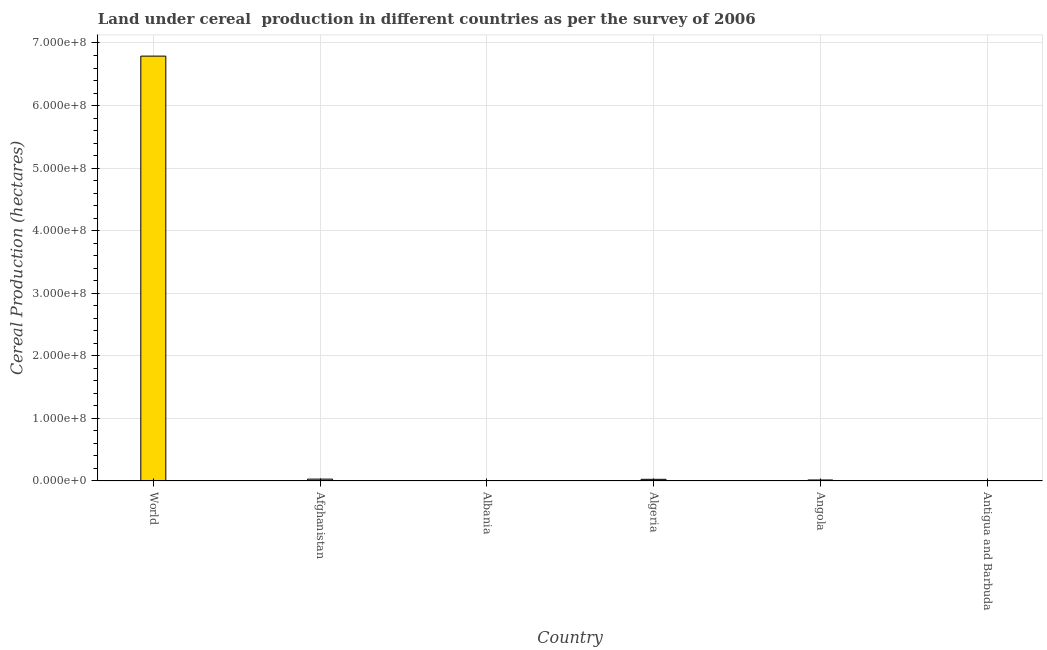Does the graph contain grids?
Ensure brevity in your answer.  Yes. What is the title of the graph?
Make the answer very short. Land under cereal  production in different countries as per the survey of 2006. What is the label or title of the X-axis?
Make the answer very short. Country. What is the label or title of the Y-axis?
Offer a very short reply. Cereal Production (hectares). What is the land under cereal production in Angola?
Offer a very short reply. 1.62e+06. Across all countries, what is the maximum land under cereal production?
Ensure brevity in your answer.  6.79e+08. In which country was the land under cereal production maximum?
Provide a short and direct response. World. In which country was the land under cereal production minimum?
Give a very brief answer. Antigua and Barbuda. What is the sum of the land under cereal production?
Give a very brief answer. 6.86e+08. What is the difference between the land under cereal production in Angola and World?
Offer a very short reply. -6.77e+08. What is the average land under cereal production per country?
Provide a succinct answer. 1.14e+08. What is the median land under cereal production?
Offer a very short reply. 2.15e+06. In how many countries, is the land under cereal production greater than 220000000 hectares?
Provide a short and direct response. 1. What is the ratio of the land under cereal production in Antigua and Barbuda to that in World?
Ensure brevity in your answer.  0. Is the land under cereal production in Afghanistan less than that in Antigua and Barbuda?
Your response must be concise. No. What is the difference between the highest and the second highest land under cereal production?
Your answer should be compact. 6.76e+08. Is the sum of the land under cereal production in Afghanistan and Antigua and Barbuda greater than the maximum land under cereal production across all countries?
Keep it short and to the point. No. What is the difference between the highest and the lowest land under cereal production?
Ensure brevity in your answer.  6.79e+08. How many bars are there?
Your response must be concise. 6. What is the difference between two consecutive major ticks on the Y-axis?
Your answer should be very brief. 1.00e+08. Are the values on the major ticks of Y-axis written in scientific E-notation?
Offer a terse response. Yes. What is the Cereal Production (hectares) of World?
Give a very brief answer. 6.79e+08. What is the Cereal Production (hectares) of Afghanistan?
Offer a very short reply. 2.99e+06. What is the Cereal Production (hectares) of Albania?
Give a very brief answer. 1.41e+05. What is the Cereal Production (hectares) of Algeria?
Offer a very short reply. 2.67e+06. What is the Cereal Production (hectares) in Angola?
Provide a short and direct response. 1.62e+06. What is the Cereal Production (hectares) of Antigua and Barbuda?
Offer a very short reply. 40. What is the difference between the Cereal Production (hectares) in World and Afghanistan?
Offer a very short reply. 6.76e+08. What is the difference between the Cereal Production (hectares) in World and Albania?
Your answer should be compact. 6.79e+08. What is the difference between the Cereal Production (hectares) in World and Algeria?
Your answer should be very brief. 6.76e+08. What is the difference between the Cereal Production (hectares) in World and Angola?
Your response must be concise. 6.77e+08. What is the difference between the Cereal Production (hectares) in World and Antigua and Barbuda?
Make the answer very short. 6.79e+08. What is the difference between the Cereal Production (hectares) in Afghanistan and Albania?
Offer a terse response. 2.85e+06. What is the difference between the Cereal Production (hectares) in Afghanistan and Algeria?
Offer a terse response. 3.17e+05. What is the difference between the Cereal Production (hectares) in Afghanistan and Angola?
Give a very brief answer. 1.37e+06. What is the difference between the Cereal Production (hectares) in Afghanistan and Antigua and Barbuda?
Give a very brief answer. 2.99e+06. What is the difference between the Cereal Production (hectares) in Albania and Algeria?
Give a very brief answer. -2.53e+06. What is the difference between the Cereal Production (hectares) in Albania and Angola?
Make the answer very short. -1.48e+06. What is the difference between the Cereal Production (hectares) in Albania and Antigua and Barbuda?
Make the answer very short. 1.41e+05. What is the difference between the Cereal Production (hectares) in Algeria and Angola?
Provide a short and direct response. 1.05e+06. What is the difference between the Cereal Production (hectares) in Algeria and Antigua and Barbuda?
Give a very brief answer. 2.67e+06. What is the difference between the Cereal Production (hectares) in Angola and Antigua and Barbuda?
Provide a short and direct response. 1.62e+06. What is the ratio of the Cereal Production (hectares) in World to that in Afghanistan?
Provide a succinct answer. 227.18. What is the ratio of the Cereal Production (hectares) in World to that in Albania?
Provide a short and direct response. 4820.25. What is the ratio of the Cereal Production (hectares) in World to that in Algeria?
Your answer should be compact. 254.11. What is the ratio of the Cereal Production (hectares) in World to that in Angola?
Ensure brevity in your answer.  418.61. What is the ratio of the Cereal Production (hectares) in World to that in Antigua and Barbuda?
Give a very brief answer. 1.70e+07. What is the ratio of the Cereal Production (hectares) in Afghanistan to that in Albania?
Your answer should be compact. 21.22. What is the ratio of the Cereal Production (hectares) in Afghanistan to that in Algeria?
Your answer should be compact. 1.12. What is the ratio of the Cereal Production (hectares) in Afghanistan to that in Angola?
Give a very brief answer. 1.84. What is the ratio of the Cereal Production (hectares) in Afghanistan to that in Antigua and Barbuda?
Keep it short and to the point. 7.47e+04. What is the ratio of the Cereal Production (hectares) in Albania to that in Algeria?
Your answer should be compact. 0.05. What is the ratio of the Cereal Production (hectares) in Albania to that in Angola?
Your answer should be compact. 0.09. What is the ratio of the Cereal Production (hectares) in Albania to that in Antigua and Barbuda?
Your response must be concise. 3521.75. What is the ratio of the Cereal Production (hectares) in Algeria to that in Angola?
Keep it short and to the point. 1.65. What is the ratio of the Cereal Production (hectares) in Algeria to that in Antigua and Barbuda?
Provide a short and direct response. 6.68e+04. What is the ratio of the Cereal Production (hectares) in Angola to that in Antigua and Barbuda?
Offer a very short reply. 4.06e+04. 